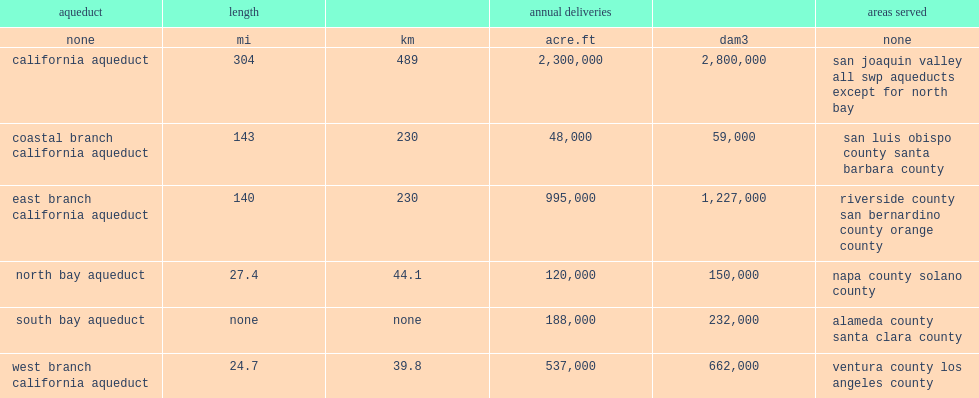How long did the coastal branch aqueduct stretch for? 143.0. 